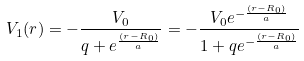<formula> <loc_0><loc_0><loc_500><loc_500>V _ { 1 } ( r ) = - \frac { V _ { 0 } } { q + e ^ { \frac { ( r - R _ { 0 } ) } { a } } } = - \frac { V _ { 0 } e ^ { - \frac { ( r - R _ { 0 } ) } { a } } } { 1 + q e ^ { - \frac { ( r - R _ { 0 } ) } { a } } }</formula> 